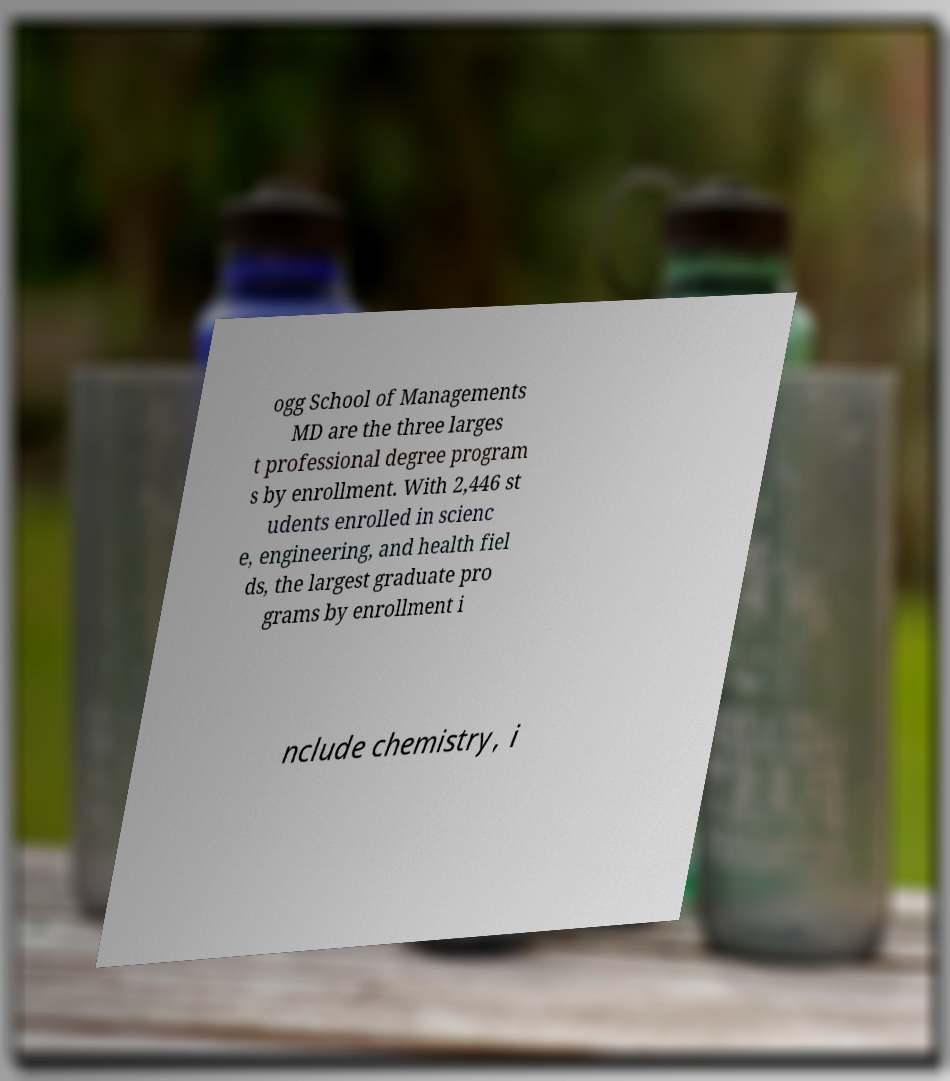Please read and relay the text visible in this image. What does it say? ogg School of Managements MD are the three larges t professional degree program s by enrollment. With 2,446 st udents enrolled in scienc e, engineering, and health fiel ds, the largest graduate pro grams by enrollment i nclude chemistry, i 